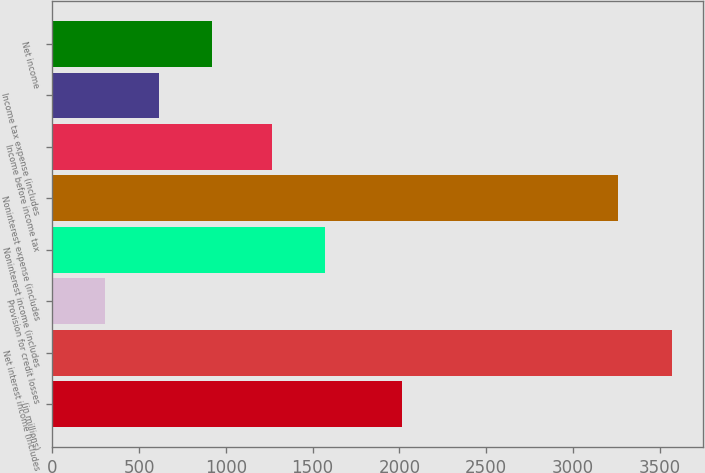Convert chart. <chart><loc_0><loc_0><loc_500><loc_500><bar_chart><fcel>(in millions)<fcel>Net interest income (includes<fcel>Provision for credit losses<fcel>Noninterest income (includes<fcel>Noninterest expense (includes<fcel>Income before income tax<fcel>Income tax expense (includes<fcel>Net income<nl><fcel>2015<fcel>3569<fcel>302<fcel>1573<fcel>3259<fcel>1263<fcel>612<fcel>922<nl></chart> 